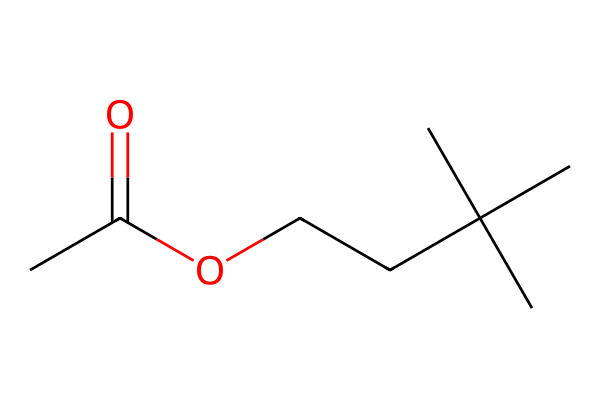How many carbon atoms are in this structure? By analyzing the SMILES notation, CC(=O)OCCC(C)(C)C, we count the carbon atoms represented by the 'C' characters. There are a total of 8 carbon atoms in the structure.
Answer: 8 What type of functional group is present in this chemical? The SMILES indicates that there is a carbonyl group (C=O) present due to the 'C(=O)' part of the notation, which defines it as an ester and indicates its reactivity and smell characteristics.
Answer: ester How many oxygen atoms are in this chemical? In the SMILES representation, the 'O' characters indicate the presence of oxygen. There are 2 oxygen atoms in CC(=O)OCCC(C)(C)C.
Answer: 2 Does this chemical contain any branches? In the structure, the notation 'C(C)(C)' indicates carbon atoms branching off a central carbon atom, which shows that the molecule has branching in its structure.
Answer: yes What smell profile can be expected from this compound? This compound, due to its ester classification and the presence of carbon chains, is typically associated with citrus and fruity aromas, which are commonly used in cleaning products.
Answer: citrus 